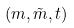Convert formula to latex. <formula><loc_0><loc_0><loc_500><loc_500>( m , \tilde { m } , t )</formula> 